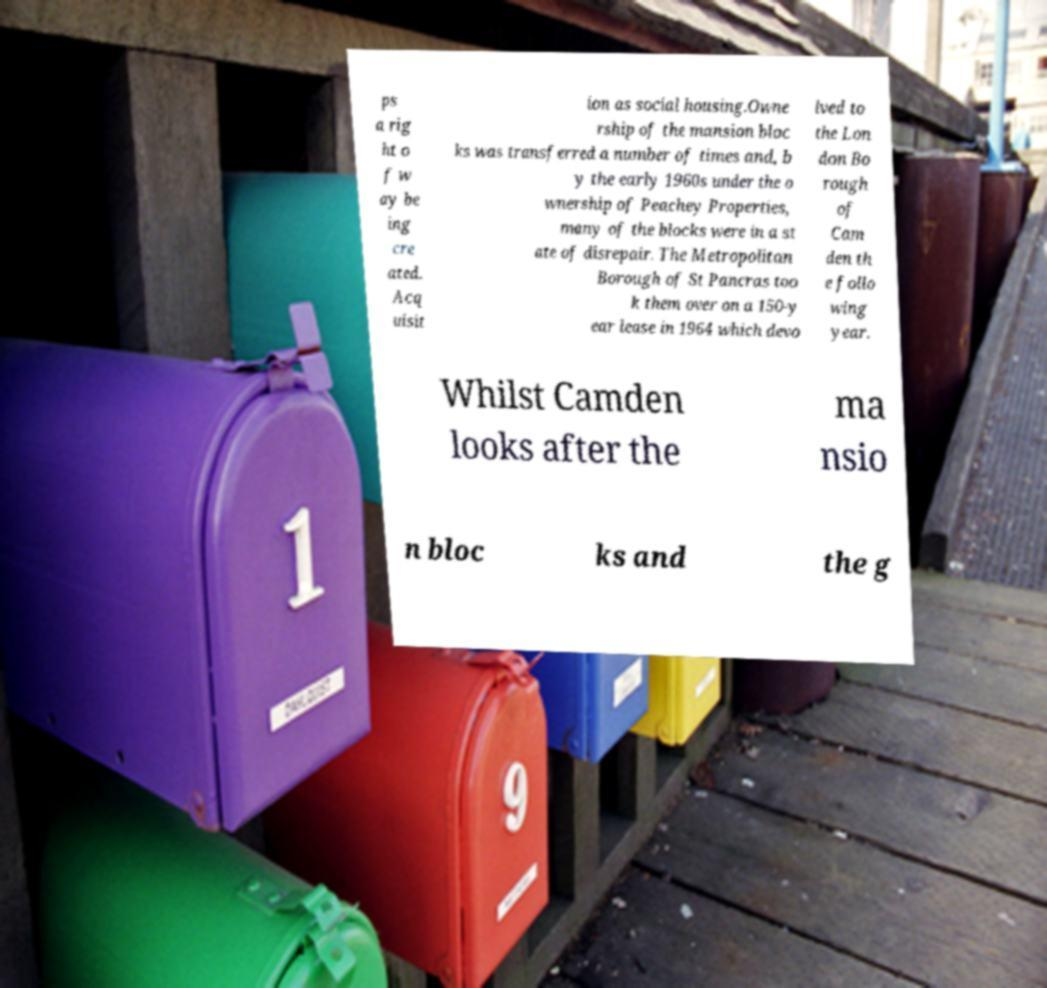For documentation purposes, I need the text within this image transcribed. Could you provide that? ps a rig ht o f w ay be ing cre ated. Acq uisit ion as social housing.Owne rship of the mansion bloc ks was transferred a number of times and, b y the early 1960s under the o wnership of Peachey Properties, many of the blocks were in a st ate of disrepair. The Metropolitan Borough of St Pancras too k them over on a 150-y ear lease in 1964 which devo lved to the Lon don Bo rough of Cam den th e follo wing year. Whilst Camden looks after the ma nsio n bloc ks and the g 